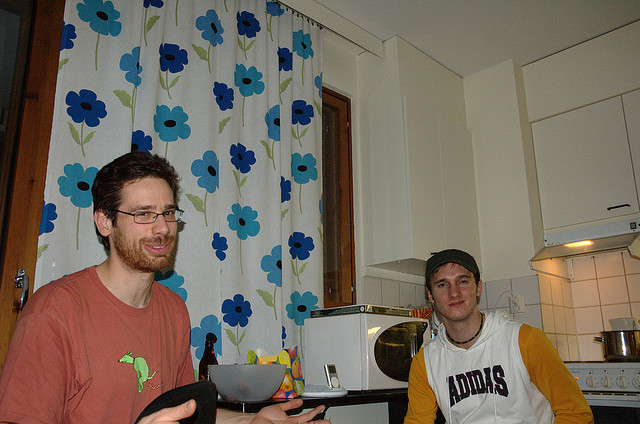Please extract the text content from this image. ADIDAS 